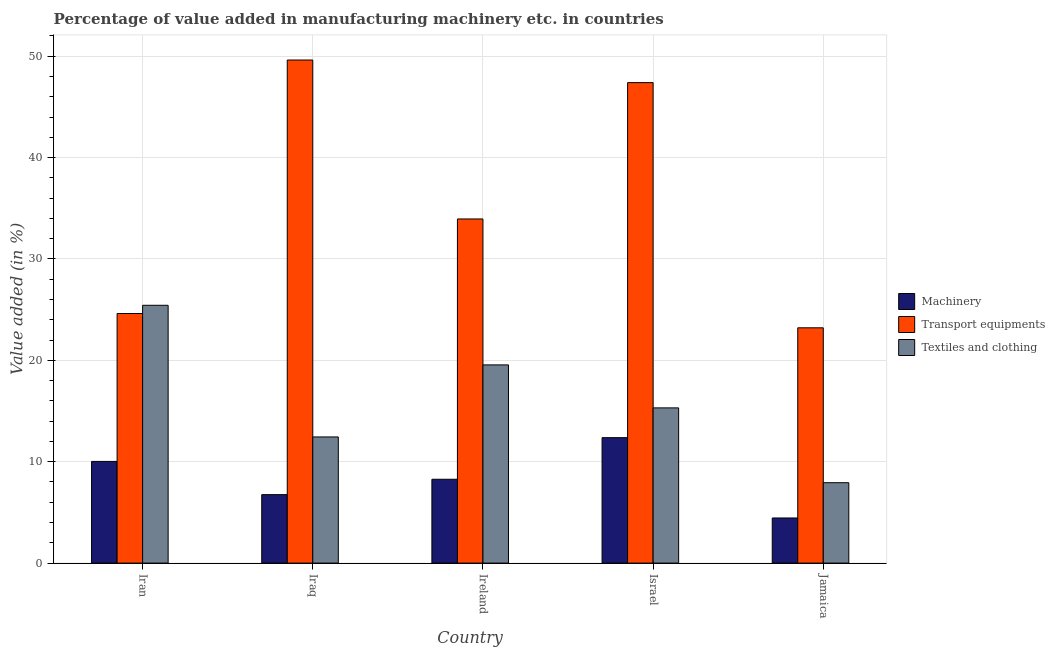How many groups of bars are there?
Make the answer very short. 5. Are the number of bars per tick equal to the number of legend labels?
Provide a short and direct response. Yes. What is the label of the 1st group of bars from the left?
Provide a short and direct response. Iran. In how many cases, is the number of bars for a given country not equal to the number of legend labels?
Your response must be concise. 0. What is the value added in manufacturing textile and clothing in Ireland?
Give a very brief answer. 19.55. Across all countries, what is the maximum value added in manufacturing textile and clothing?
Give a very brief answer. 25.43. Across all countries, what is the minimum value added in manufacturing textile and clothing?
Offer a very short reply. 7.93. In which country was the value added in manufacturing transport equipments maximum?
Your response must be concise. Iraq. In which country was the value added in manufacturing textile and clothing minimum?
Your answer should be compact. Jamaica. What is the total value added in manufacturing machinery in the graph?
Provide a short and direct response. 41.88. What is the difference between the value added in manufacturing machinery in Israel and that in Jamaica?
Your response must be concise. 7.92. What is the difference between the value added in manufacturing machinery in Iran and the value added in manufacturing transport equipments in Jamaica?
Offer a terse response. -13.18. What is the average value added in manufacturing machinery per country?
Your answer should be compact. 8.38. What is the difference between the value added in manufacturing textile and clothing and value added in manufacturing transport equipments in Jamaica?
Your answer should be very brief. -15.28. What is the ratio of the value added in manufacturing textile and clothing in Iran to that in Iraq?
Offer a terse response. 2.04. Is the difference between the value added in manufacturing transport equipments in Iraq and Jamaica greater than the difference between the value added in manufacturing textile and clothing in Iraq and Jamaica?
Offer a very short reply. Yes. What is the difference between the highest and the second highest value added in manufacturing transport equipments?
Provide a succinct answer. 2.23. What is the difference between the highest and the lowest value added in manufacturing machinery?
Your response must be concise. 7.92. Is the sum of the value added in manufacturing textile and clothing in Ireland and Israel greater than the maximum value added in manufacturing machinery across all countries?
Give a very brief answer. Yes. What does the 1st bar from the left in Jamaica represents?
Offer a very short reply. Machinery. What does the 3rd bar from the right in Jamaica represents?
Provide a succinct answer. Machinery. Is it the case that in every country, the sum of the value added in manufacturing machinery and value added in manufacturing transport equipments is greater than the value added in manufacturing textile and clothing?
Make the answer very short. Yes. How many bars are there?
Offer a very short reply. 15. How many countries are there in the graph?
Offer a terse response. 5. What is the difference between two consecutive major ticks on the Y-axis?
Provide a short and direct response. 10. Are the values on the major ticks of Y-axis written in scientific E-notation?
Offer a terse response. No. Does the graph contain any zero values?
Provide a short and direct response. No. How many legend labels are there?
Give a very brief answer. 3. What is the title of the graph?
Provide a short and direct response. Percentage of value added in manufacturing machinery etc. in countries. Does "Renewable sources" appear as one of the legend labels in the graph?
Provide a succinct answer. No. What is the label or title of the X-axis?
Provide a short and direct response. Country. What is the label or title of the Y-axis?
Provide a succinct answer. Value added (in %). What is the Value added (in %) of Machinery in Iran?
Make the answer very short. 10.03. What is the Value added (in %) in Transport equipments in Iran?
Offer a very short reply. 24.62. What is the Value added (in %) in Textiles and clothing in Iran?
Provide a short and direct response. 25.43. What is the Value added (in %) of Machinery in Iraq?
Provide a succinct answer. 6.75. What is the Value added (in %) in Transport equipments in Iraq?
Provide a succinct answer. 49.62. What is the Value added (in %) in Textiles and clothing in Iraq?
Give a very brief answer. 12.44. What is the Value added (in %) in Machinery in Ireland?
Your answer should be compact. 8.27. What is the Value added (in %) of Transport equipments in Ireland?
Your answer should be compact. 33.95. What is the Value added (in %) of Textiles and clothing in Ireland?
Make the answer very short. 19.55. What is the Value added (in %) in Machinery in Israel?
Provide a short and direct response. 12.37. What is the Value added (in %) of Transport equipments in Israel?
Your answer should be compact. 47.4. What is the Value added (in %) in Textiles and clothing in Israel?
Your answer should be compact. 15.31. What is the Value added (in %) of Machinery in Jamaica?
Make the answer very short. 4.45. What is the Value added (in %) in Transport equipments in Jamaica?
Make the answer very short. 23.21. What is the Value added (in %) of Textiles and clothing in Jamaica?
Give a very brief answer. 7.93. Across all countries, what is the maximum Value added (in %) in Machinery?
Offer a very short reply. 12.37. Across all countries, what is the maximum Value added (in %) in Transport equipments?
Make the answer very short. 49.62. Across all countries, what is the maximum Value added (in %) of Textiles and clothing?
Keep it short and to the point. 25.43. Across all countries, what is the minimum Value added (in %) of Machinery?
Offer a very short reply. 4.45. Across all countries, what is the minimum Value added (in %) in Transport equipments?
Offer a very short reply. 23.21. Across all countries, what is the minimum Value added (in %) in Textiles and clothing?
Your response must be concise. 7.93. What is the total Value added (in %) of Machinery in the graph?
Offer a very short reply. 41.88. What is the total Value added (in %) in Transport equipments in the graph?
Provide a succinct answer. 178.79. What is the total Value added (in %) in Textiles and clothing in the graph?
Ensure brevity in your answer.  80.67. What is the difference between the Value added (in %) in Machinery in Iran and that in Iraq?
Give a very brief answer. 3.28. What is the difference between the Value added (in %) in Transport equipments in Iran and that in Iraq?
Give a very brief answer. -25. What is the difference between the Value added (in %) in Textiles and clothing in Iran and that in Iraq?
Offer a terse response. 12.99. What is the difference between the Value added (in %) of Machinery in Iran and that in Ireland?
Keep it short and to the point. 1.76. What is the difference between the Value added (in %) of Transport equipments in Iran and that in Ireland?
Provide a succinct answer. -9.33. What is the difference between the Value added (in %) of Textiles and clothing in Iran and that in Ireland?
Keep it short and to the point. 5.88. What is the difference between the Value added (in %) of Machinery in Iran and that in Israel?
Offer a very short reply. -2.34. What is the difference between the Value added (in %) of Transport equipments in Iran and that in Israel?
Make the answer very short. -22.78. What is the difference between the Value added (in %) in Textiles and clothing in Iran and that in Israel?
Your response must be concise. 10.12. What is the difference between the Value added (in %) in Machinery in Iran and that in Jamaica?
Your answer should be very brief. 5.58. What is the difference between the Value added (in %) of Transport equipments in Iran and that in Jamaica?
Ensure brevity in your answer.  1.41. What is the difference between the Value added (in %) of Textiles and clothing in Iran and that in Jamaica?
Make the answer very short. 17.5. What is the difference between the Value added (in %) of Machinery in Iraq and that in Ireland?
Your response must be concise. -1.52. What is the difference between the Value added (in %) of Transport equipments in Iraq and that in Ireland?
Provide a short and direct response. 15.68. What is the difference between the Value added (in %) of Textiles and clothing in Iraq and that in Ireland?
Give a very brief answer. -7.11. What is the difference between the Value added (in %) of Machinery in Iraq and that in Israel?
Provide a short and direct response. -5.62. What is the difference between the Value added (in %) in Transport equipments in Iraq and that in Israel?
Your answer should be compact. 2.23. What is the difference between the Value added (in %) of Textiles and clothing in Iraq and that in Israel?
Offer a very short reply. -2.87. What is the difference between the Value added (in %) of Machinery in Iraq and that in Jamaica?
Ensure brevity in your answer.  2.3. What is the difference between the Value added (in %) of Transport equipments in Iraq and that in Jamaica?
Provide a short and direct response. 26.41. What is the difference between the Value added (in %) in Textiles and clothing in Iraq and that in Jamaica?
Ensure brevity in your answer.  4.52. What is the difference between the Value added (in %) in Machinery in Ireland and that in Israel?
Provide a short and direct response. -4.1. What is the difference between the Value added (in %) in Transport equipments in Ireland and that in Israel?
Offer a very short reply. -13.45. What is the difference between the Value added (in %) of Textiles and clothing in Ireland and that in Israel?
Offer a very short reply. 4.24. What is the difference between the Value added (in %) in Machinery in Ireland and that in Jamaica?
Your answer should be very brief. 3.82. What is the difference between the Value added (in %) of Transport equipments in Ireland and that in Jamaica?
Your answer should be compact. 10.74. What is the difference between the Value added (in %) in Textiles and clothing in Ireland and that in Jamaica?
Offer a terse response. 11.62. What is the difference between the Value added (in %) in Machinery in Israel and that in Jamaica?
Your answer should be compact. 7.92. What is the difference between the Value added (in %) in Transport equipments in Israel and that in Jamaica?
Keep it short and to the point. 24.19. What is the difference between the Value added (in %) in Textiles and clothing in Israel and that in Jamaica?
Offer a terse response. 7.38. What is the difference between the Value added (in %) of Machinery in Iran and the Value added (in %) of Transport equipments in Iraq?
Make the answer very short. -39.59. What is the difference between the Value added (in %) in Machinery in Iran and the Value added (in %) in Textiles and clothing in Iraq?
Provide a succinct answer. -2.41. What is the difference between the Value added (in %) of Transport equipments in Iran and the Value added (in %) of Textiles and clothing in Iraq?
Your answer should be compact. 12.17. What is the difference between the Value added (in %) in Machinery in Iran and the Value added (in %) in Transport equipments in Ireland?
Provide a short and direct response. -23.92. What is the difference between the Value added (in %) of Machinery in Iran and the Value added (in %) of Textiles and clothing in Ireland?
Your response must be concise. -9.52. What is the difference between the Value added (in %) in Transport equipments in Iran and the Value added (in %) in Textiles and clothing in Ireland?
Ensure brevity in your answer.  5.07. What is the difference between the Value added (in %) of Machinery in Iran and the Value added (in %) of Transport equipments in Israel?
Provide a succinct answer. -37.37. What is the difference between the Value added (in %) of Machinery in Iran and the Value added (in %) of Textiles and clothing in Israel?
Ensure brevity in your answer.  -5.28. What is the difference between the Value added (in %) of Transport equipments in Iran and the Value added (in %) of Textiles and clothing in Israel?
Make the answer very short. 9.31. What is the difference between the Value added (in %) in Machinery in Iran and the Value added (in %) in Transport equipments in Jamaica?
Make the answer very short. -13.18. What is the difference between the Value added (in %) of Machinery in Iran and the Value added (in %) of Textiles and clothing in Jamaica?
Your response must be concise. 2.1. What is the difference between the Value added (in %) of Transport equipments in Iran and the Value added (in %) of Textiles and clothing in Jamaica?
Keep it short and to the point. 16.69. What is the difference between the Value added (in %) of Machinery in Iraq and the Value added (in %) of Transport equipments in Ireland?
Your answer should be very brief. -27.19. What is the difference between the Value added (in %) of Machinery in Iraq and the Value added (in %) of Textiles and clothing in Ireland?
Offer a very short reply. -12.8. What is the difference between the Value added (in %) in Transport equipments in Iraq and the Value added (in %) in Textiles and clothing in Ireland?
Keep it short and to the point. 30.07. What is the difference between the Value added (in %) of Machinery in Iraq and the Value added (in %) of Transport equipments in Israel?
Ensure brevity in your answer.  -40.64. What is the difference between the Value added (in %) of Machinery in Iraq and the Value added (in %) of Textiles and clothing in Israel?
Provide a succinct answer. -8.56. What is the difference between the Value added (in %) of Transport equipments in Iraq and the Value added (in %) of Textiles and clothing in Israel?
Your response must be concise. 34.31. What is the difference between the Value added (in %) in Machinery in Iraq and the Value added (in %) in Transport equipments in Jamaica?
Give a very brief answer. -16.46. What is the difference between the Value added (in %) of Machinery in Iraq and the Value added (in %) of Textiles and clothing in Jamaica?
Ensure brevity in your answer.  -1.18. What is the difference between the Value added (in %) in Transport equipments in Iraq and the Value added (in %) in Textiles and clothing in Jamaica?
Offer a terse response. 41.69. What is the difference between the Value added (in %) of Machinery in Ireland and the Value added (in %) of Transport equipments in Israel?
Provide a succinct answer. -39.13. What is the difference between the Value added (in %) in Machinery in Ireland and the Value added (in %) in Textiles and clothing in Israel?
Give a very brief answer. -7.04. What is the difference between the Value added (in %) of Transport equipments in Ireland and the Value added (in %) of Textiles and clothing in Israel?
Your response must be concise. 18.64. What is the difference between the Value added (in %) of Machinery in Ireland and the Value added (in %) of Transport equipments in Jamaica?
Make the answer very short. -14.94. What is the difference between the Value added (in %) of Machinery in Ireland and the Value added (in %) of Textiles and clothing in Jamaica?
Keep it short and to the point. 0.34. What is the difference between the Value added (in %) in Transport equipments in Ireland and the Value added (in %) in Textiles and clothing in Jamaica?
Ensure brevity in your answer.  26.02. What is the difference between the Value added (in %) in Machinery in Israel and the Value added (in %) in Transport equipments in Jamaica?
Make the answer very short. -10.84. What is the difference between the Value added (in %) in Machinery in Israel and the Value added (in %) in Textiles and clothing in Jamaica?
Ensure brevity in your answer.  4.44. What is the difference between the Value added (in %) of Transport equipments in Israel and the Value added (in %) of Textiles and clothing in Jamaica?
Offer a terse response. 39.47. What is the average Value added (in %) of Machinery per country?
Provide a succinct answer. 8.38. What is the average Value added (in %) of Transport equipments per country?
Provide a short and direct response. 35.76. What is the average Value added (in %) of Textiles and clothing per country?
Your response must be concise. 16.13. What is the difference between the Value added (in %) of Machinery and Value added (in %) of Transport equipments in Iran?
Your answer should be very brief. -14.59. What is the difference between the Value added (in %) in Machinery and Value added (in %) in Textiles and clothing in Iran?
Provide a short and direct response. -15.4. What is the difference between the Value added (in %) in Transport equipments and Value added (in %) in Textiles and clothing in Iran?
Ensure brevity in your answer.  -0.81. What is the difference between the Value added (in %) in Machinery and Value added (in %) in Transport equipments in Iraq?
Your response must be concise. -42.87. What is the difference between the Value added (in %) of Machinery and Value added (in %) of Textiles and clothing in Iraq?
Provide a short and direct response. -5.69. What is the difference between the Value added (in %) in Transport equipments and Value added (in %) in Textiles and clothing in Iraq?
Ensure brevity in your answer.  37.18. What is the difference between the Value added (in %) of Machinery and Value added (in %) of Transport equipments in Ireland?
Provide a succinct answer. -25.68. What is the difference between the Value added (in %) in Machinery and Value added (in %) in Textiles and clothing in Ireland?
Provide a succinct answer. -11.28. What is the difference between the Value added (in %) in Transport equipments and Value added (in %) in Textiles and clothing in Ireland?
Your answer should be very brief. 14.4. What is the difference between the Value added (in %) in Machinery and Value added (in %) in Transport equipments in Israel?
Offer a terse response. -35.02. What is the difference between the Value added (in %) of Machinery and Value added (in %) of Textiles and clothing in Israel?
Your answer should be very brief. -2.94. What is the difference between the Value added (in %) in Transport equipments and Value added (in %) in Textiles and clothing in Israel?
Offer a terse response. 32.08. What is the difference between the Value added (in %) in Machinery and Value added (in %) in Transport equipments in Jamaica?
Offer a very short reply. -18.76. What is the difference between the Value added (in %) of Machinery and Value added (in %) of Textiles and clothing in Jamaica?
Your answer should be very brief. -3.48. What is the difference between the Value added (in %) in Transport equipments and Value added (in %) in Textiles and clothing in Jamaica?
Ensure brevity in your answer.  15.28. What is the ratio of the Value added (in %) of Machinery in Iran to that in Iraq?
Your answer should be compact. 1.49. What is the ratio of the Value added (in %) in Transport equipments in Iran to that in Iraq?
Your answer should be compact. 0.5. What is the ratio of the Value added (in %) of Textiles and clothing in Iran to that in Iraq?
Your answer should be compact. 2.04. What is the ratio of the Value added (in %) in Machinery in Iran to that in Ireland?
Offer a terse response. 1.21. What is the ratio of the Value added (in %) in Transport equipments in Iran to that in Ireland?
Your answer should be very brief. 0.73. What is the ratio of the Value added (in %) of Textiles and clothing in Iran to that in Ireland?
Your answer should be very brief. 1.3. What is the ratio of the Value added (in %) of Machinery in Iran to that in Israel?
Your answer should be compact. 0.81. What is the ratio of the Value added (in %) in Transport equipments in Iran to that in Israel?
Your answer should be very brief. 0.52. What is the ratio of the Value added (in %) in Textiles and clothing in Iran to that in Israel?
Offer a terse response. 1.66. What is the ratio of the Value added (in %) of Machinery in Iran to that in Jamaica?
Keep it short and to the point. 2.25. What is the ratio of the Value added (in %) of Transport equipments in Iran to that in Jamaica?
Give a very brief answer. 1.06. What is the ratio of the Value added (in %) in Textiles and clothing in Iran to that in Jamaica?
Your answer should be very brief. 3.21. What is the ratio of the Value added (in %) in Machinery in Iraq to that in Ireland?
Offer a terse response. 0.82. What is the ratio of the Value added (in %) of Transport equipments in Iraq to that in Ireland?
Your answer should be compact. 1.46. What is the ratio of the Value added (in %) in Textiles and clothing in Iraq to that in Ireland?
Your answer should be very brief. 0.64. What is the ratio of the Value added (in %) in Machinery in Iraq to that in Israel?
Ensure brevity in your answer.  0.55. What is the ratio of the Value added (in %) in Transport equipments in Iraq to that in Israel?
Your answer should be very brief. 1.05. What is the ratio of the Value added (in %) of Textiles and clothing in Iraq to that in Israel?
Provide a short and direct response. 0.81. What is the ratio of the Value added (in %) of Machinery in Iraq to that in Jamaica?
Ensure brevity in your answer.  1.52. What is the ratio of the Value added (in %) in Transport equipments in Iraq to that in Jamaica?
Offer a very short reply. 2.14. What is the ratio of the Value added (in %) of Textiles and clothing in Iraq to that in Jamaica?
Provide a short and direct response. 1.57. What is the ratio of the Value added (in %) of Machinery in Ireland to that in Israel?
Make the answer very short. 0.67. What is the ratio of the Value added (in %) in Transport equipments in Ireland to that in Israel?
Provide a succinct answer. 0.72. What is the ratio of the Value added (in %) in Textiles and clothing in Ireland to that in Israel?
Your answer should be compact. 1.28. What is the ratio of the Value added (in %) of Machinery in Ireland to that in Jamaica?
Provide a short and direct response. 1.86. What is the ratio of the Value added (in %) in Transport equipments in Ireland to that in Jamaica?
Offer a terse response. 1.46. What is the ratio of the Value added (in %) of Textiles and clothing in Ireland to that in Jamaica?
Your answer should be very brief. 2.47. What is the ratio of the Value added (in %) of Machinery in Israel to that in Jamaica?
Make the answer very short. 2.78. What is the ratio of the Value added (in %) in Transport equipments in Israel to that in Jamaica?
Provide a short and direct response. 2.04. What is the ratio of the Value added (in %) in Textiles and clothing in Israel to that in Jamaica?
Your response must be concise. 1.93. What is the difference between the highest and the second highest Value added (in %) of Machinery?
Keep it short and to the point. 2.34. What is the difference between the highest and the second highest Value added (in %) of Transport equipments?
Keep it short and to the point. 2.23. What is the difference between the highest and the second highest Value added (in %) of Textiles and clothing?
Your response must be concise. 5.88. What is the difference between the highest and the lowest Value added (in %) of Machinery?
Make the answer very short. 7.92. What is the difference between the highest and the lowest Value added (in %) of Transport equipments?
Your response must be concise. 26.41. What is the difference between the highest and the lowest Value added (in %) in Textiles and clothing?
Your response must be concise. 17.5. 